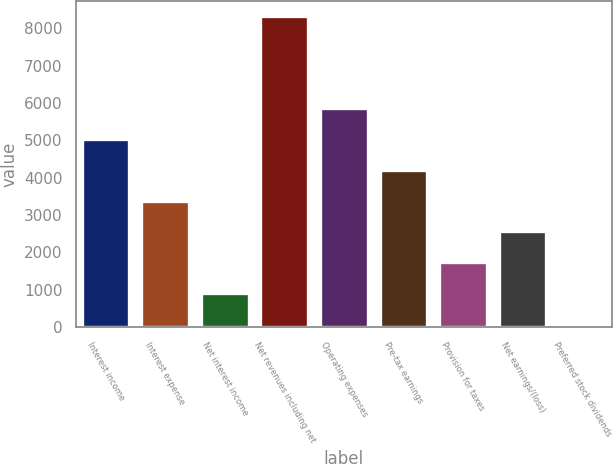<chart> <loc_0><loc_0><loc_500><loc_500><bar_chart><fcel>Interest income<fcel>Interest expense<fcel>Net interest income<fcel>Net revenues including net<fcel>Operating expenses<fcel>Pre-tax earnings<fcel>Provision for taxes<fcel>Net earnings/(loss)<fcel>Preferred stock dividends<nl><fcel>5032.8<fcel>3386.2<fcel>916.3<fcel>8326<fcel>5856.1<fcel>4209.5<fcel>1739.6<fcel>2562.9<fcel>93<nl></chart> 